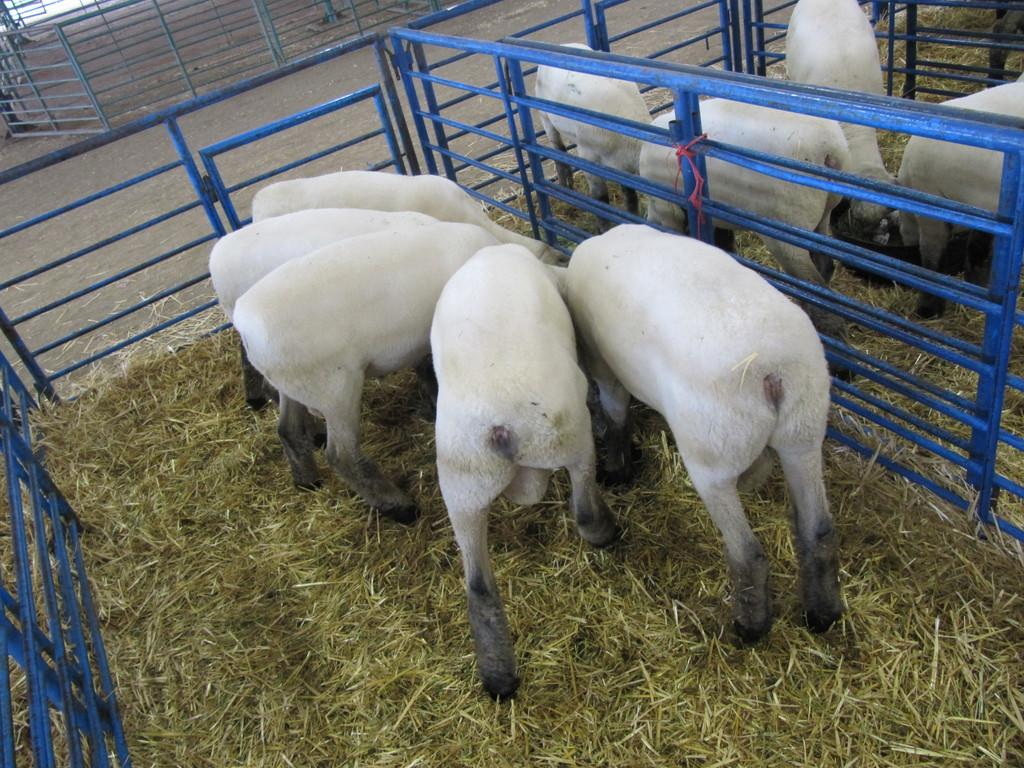What type of living organisms are in the image? There are animals in the image. What are the animals doing in the image? The animals are eating grass. What is the purpose of the metal fence in the image? The metal fence is likely there to contain or separate the animals. What color crayon is being used by the kittens in the image? There are no kittens present in the image, and therefore no crayons or coloring activity can be observed. 